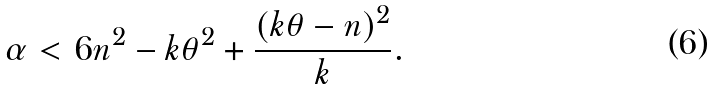Convert formula to latex. <formula><loc_0><loc_0><loc_500><loc_500>\alpha < 6 n ^ { 2 } - k \theta ^ { 2 } + \frac { ( k \theta - n ) ^ { 2 } } k .</formula> 